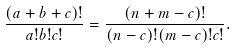Convert formula to latex. <formula><loc_0><loc_0><loc_500><loc_500>\frac { ( a + b + c ) ! } { a ! b ! c ! } = \frac { ( n + m - c ) ! } { ( n - c ) ! ( m - c ) ! c ! } .</formula> 